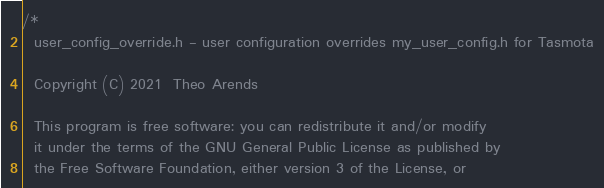Convert code to text. <code><loc_0><loc_0><loc_500><loc_500><_C_>/*
  user_config_override.h - user configuration overrides my_user_config.h for Tasmota

  Copyright (C) 2021  Theo Arends

  This program is free software: you can redistribute it and/or modify
  it under the terms of the GNU General Public License as published by
  the Free Software Foundation, either version 3 of the License, or</code> 